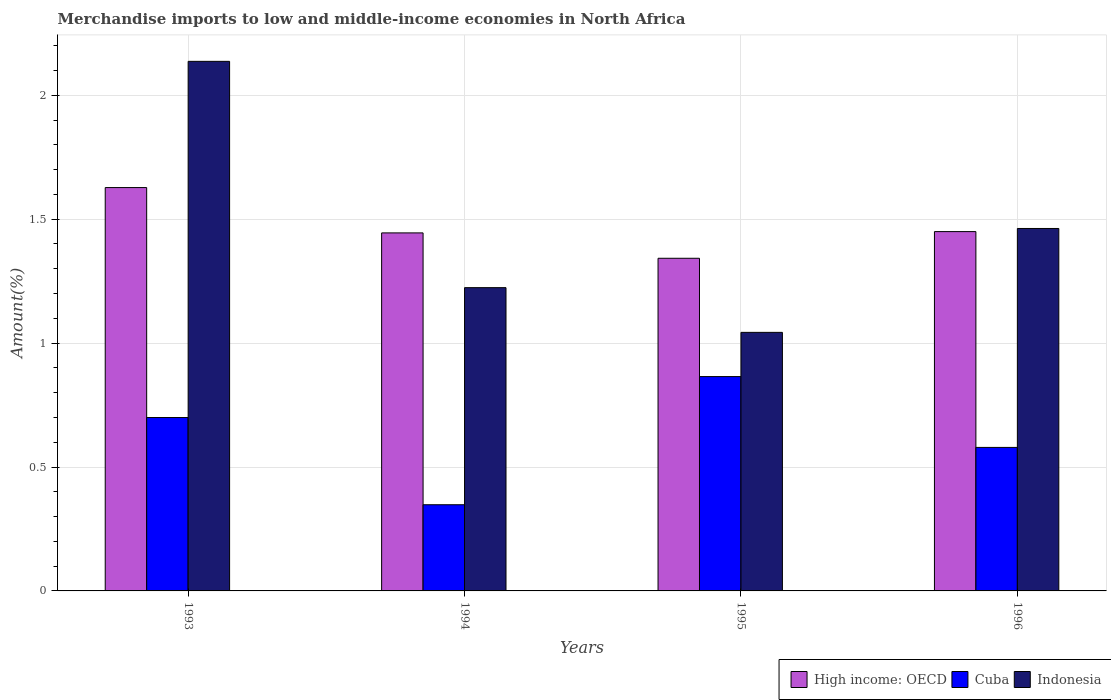How many different coloured bars are there?
Keep it short and to the point. 3. In how many cases, is the number of bars for a given year not equal to the number of legend labels?
Keep it short and to the point. 0. What is the percentage of amount earned from merchandise imports in Indonesia in 1995?
Provide a short and direct response. 1.04. Across all years, what is the maximum percentage of amount earned from merchandise imports in High income: OECD?
Your answer should be compact. 1.63. Across all years, what is the minimum percentage of amount earned from merchandise imports in High income: OECD?
Provide a succinct answer. 1.34. What is the total percentage of amount earned from merchandise imports in Cuba in the graph?
Ensure brevity in your answer.  2.49. What is the difference between the percentage of amount earned from merchandise imports in High income: OECD in 1993 and that in 1995?
Your answer should be compact. 0.29. What is the difference between the percentage of amount earned from merchandise imports in High income: OECD in 1996 and the percentage of amount earned from merchandise imports in Indonesia in 1995?
Your response must be concise. 0.41. What is the average percentage of amount earned from merchandise imports in Cuba per year?
Your answer should be compact. 0.62. In the year 1994, what is the difference between the percentage of amount earned from merchandise imports in Cuba and percentage of amount earned from merchandise imports in High income: OECD?
Your answer should be compact. -1.1. In how many years, is the percentage of amount earned from merchandise imports in Cuba greater than 1.6 %?
Give a very brief answer. 0. What is the ratio of the percentage of amount earned from merchandise imports in Indonesia in 1994 to that in 1995?
Your answer should be compact. 1.17. What is the difference between the highest and the second highest percentage of amount earned from merchandise imports in Cuba?
Give a very brief answer. 0.17. What is the difference between the highest and the lowest percentage of amount earned from merchandise imports in Cuba?
Offer a terse response. 0.52. In how many years, is the percentage of amount earned from merchandise imports in Indonesia greater than the average percentage of amount earned from merchandise imports in Indonesia taken over all years?
Provide a succinct answer. 1. What does the 1st bar from the right in 1993 represents?
Keep it short and to the point. Indonesia. Does the graph contain any zero values?
Offer a terse response. No. Does the graph contain grids?
Offer a very short reply. Yes. How many legend labels are there?
Your response must be concise. 3. How are the legend labels stacked?
Keep it short and to the point. Horizontal. What is the title of the graph?
Give a very brief answer. Merchandise imports to low and middle-income economies in North Africa. What is the label or title of the Y-axis?
Ensure brevity in your answer.  Amount(%). What is the Amount(%) in High income: OECD in 1993?
Offer a very short reply. 1.63. What is the Amount(%) in Cuba in 1993?
Give a very brief answer. 0.7. What is the Amount(%) of Indonesia in 1993?
Give a very brief answer. 2.14. What is the Amount(%) in High income: OECD in 1994?
Ensure brevity in your answer.  1.44. What is the Amount(%) in Cuba in 1994?
Offer a terse response. 0.35. What is the Amount(%) of Indonesia in 1994?
Make the answer very short. 1.22. What is the Amount(%) of High income: OECD in 1995?
Keep it short and to the point. 1.34. What is the Amount(%) in Cuba in 1995?
Your response must be concise. 0.86. What is the Amount(%) of Indonesia in 1995?
Provide a short and direct response. 1.04. What is the Amount(%) of High income: OECD in 1996?
Provide a succinct answer. 1.45. What is the Amount(%) in Cuba in 1996?
Your answer should be very brief. 0.58. What is the Amount(%) of Indonesia in 1996?
Offer a very short reply. 1.46. Across all years, what is the maximum Amount(%) of High income: OECD?
Make the answer very short. 1.63. Across all years, what is the maximum Amount(%) in Cuba?
Ensure brevity in your answer.  0.86. Across all years, what is the maximum Amount(%) in Indonesia?
Provide a short and direct response. 2.14. Across all years, what is the minimum Amount(%) in High income: OECD?
Ensure brevity in your answer.  1.34. Across all years, what is the minimum Amount(%) of Cuba?
Your answer should be compact. 0.35. Across all years, what is the minimum Amount(%) in Indonesia?
Offer a very short reply. 1.04. What is the total Amount(%) in High income: OECD in the graph?
Keep it short and to the point. 5.86. What is the total Amount(%) of Cuba in the graph?
Provide a short and direct response. 2.49. What is the total Amount(%) of Indonesia in the graph?
Your response must be concise. 5.87. What is the difference between the Amount(%) in High income: OECD in 1993 and that in 1994?
Your response must be concise. 0.18. What is the difference between the Amount(%) of Cuba in 1993 and that in 1994?
Keep it short and to the point. 0.35. What is the difference between the Amount(%) in Indonesia in 1993 and that in 1994?
Your answer should be very brief. 0.91. What is the difference between the Amount(%) of High income: OECD in 1993 and that in 1995?
Make the answer very short. 0.29. What is the difference between the Amount(%) of Cuba in 1993 and that in 1995?
Provide a short and direct response. -0.17. What is the difference between the Amount(%) of Indonesia in 1993 and that in 1995?
Offer a very short reply. 1.09. What is the difference between the Amount(%) of High income: OECD in 1993 and that in 1996?
Give a very brief answer. 0.18. What is the difference between the Amount(%) of Cuba in 1993 and that in 1996?
Provide a short and direct response. 0.12. What is the difference between the Amount(%) of Indonesia in 1993 and that in 1996?
Ensure brevity in your answer.  0.67. What is the difference between the Amount(%) in High income: OECD in 1994 and that in 1995?
Your answer should be very brief. 0.1. What is the difference between the Amount(%) in Cuba in 1994 and that in 1995?
Offer a terse response. -0.52. What is the difference between the Amount(%) of Indonesia in 1994 and that in 1995?
Offer a terse response. 0.18. What is the difference between the Amount(%) of High income: OECD in 1994 and that in 1996?
Offer a terse response. -0.01. What is the difference between the Amount(%) in Cuba in 1994 and that in 1996?
Your answer should be very brief. -0.23. What is the difference between the Amount(%) of Indonesia in 1994 and that in 1996?
Offer a terse response. -0.24. What is the difference between the Amount(%) in High income: OECD in 1995 and that in 1996?
Offer a terse response. -0.11. What is the difference between the Amount(%) of Cuba in 1995 and that in 1996?
Make the answer very short. 0.29. What is the difference between the Amount(%) in Indonesia in 1995 and that in 1996?
Your answer should be very brief. -0.42. What is the difference between the Amount(%) of High income: OECD in 1993 and the Amount(%) of Cuba in 1994?
Offer a very short reply. 1.28. What is the difference between the Amount(%) in High income: OECD in 1993 and the Amount(%) in Indonesia in 1994?
Ensure brevity in your answer.  0.4. What is the difference between the Amount(%) of Cuba in 1993 and the Amount(%) of Indonesia in 1994?
Your answer should be very brief. -0.52. What is the difference between the Amount(%) of High income: OECD in 1993 and the Amount(%) of Cuba in 1995?
Your answer should be very brief. 0.76. What is the difference between the Amount(%) in High income: OECD in 1993 and the Amount(%) in Indonesia in 1995?
Offer a terse response. 0.58. What is the difference between the Amount(%) of Cuba in 1993 and the Amount(%) of Indonesia in 1995?
Keep it short and to the point. -0.34. What is the difference between the Amount(%) in High income: OECD in 1993 and the Amount(%) in Cuba in 1996?
Your answer should be very brief. 1.05. What is the difference between the Amount(%) of High income: OECD in 1993 and the Amount(%) of Indonesia in 1996?
Offer a very short reply. 0.17. What is the difference between the Amount(%) of Cuba in 1993 and the Amount(%) of Indonesia in 1996?
Ensure brevity in your answer.  -0.76. What is the difference between the Amount(%) of High income: OECD in 1994 and the Amount(%) of Cuba in 1995?
Offer a terse response. 0.58. What is the difference between the Amount(%) in High income: OECD in 1994 and the Amount(%) in Indonesia in 1995?
Give a very brief answer. 0.4. What is the difference between the Amount(%) in Cuba in 1994 and the Amount(%) in Indonesia in 1995?
Provide a succinct answer. -0.7. What is the difference between the Amount(%) in High income: OECD in 1994 and the Amount(%) in Cuba in 1996?
Your answer should be compact. 0.87. What is the difference between the Amount(%) in High income: OECD in 1994 and the Amount(%) in Indonesia in 1996?
Provide a succinct answer. -0.02. What is the difference between the Amount(%) in Cuba in 1994 and the Amount(%) in Indonesia in 1996?
Make the answer very short. -1.11. What is the difference between the Amount(%) in High income: OECD in 1995 and the Amount(%) in Cuba in 1996?
Ensure brevity in your answer.  0.76. What is the difference between the Amount(%) of High income: OECD in 1995 and the Amount(%) of Indonesia in 1996?
Ensure brevity in your answer.  -0.12. What is the difference between the Amount(%) of Cuba in 1995 and the Amount(%) of Indonesia in 1996?
Ensure brevity in your answer.  -0.6. What is the average Amount(%) of High income: OECD per year?
Make the answer very short. 1.47. What is the average Amount(%) in Cuba per year?
Give a very brief answer. 0.62. What is the average Amount(%) in Indonesia per year?
Keep it short and to the point. 1.47. In the year 1993, what is the difference between the Amount(%) in High income: OECD and Amount(%) in Cuba?
Offer a terse response. 0.93. In the year 1993, what is the difference between the Amount(%) of High income: OECD and Amount(%) of Indonesia?
Offer a terse response. -0.51. In the year 1993, what is the difference between the Amount(%) in Cuba and Amount(%) in Indonesia?
Your response must be concise. -1.44. In the year 1994, what is the difference between the Amount(%) of High income: OECD and Amount(%) of Cuba?
Your answer should be very brief. 1.1. In the year 1994, what is the difference between the Amount(%) in High income: OECD and Amount(%) in Indonesia?
Your answer should be very brief. 0.22. In the year 1994, what is the difference between the Amount(%) in Cuba and Amount(%) in Indonesia?
Provide a short and direct response. -0.88. In the year 1995, what is the difference between the Amount(%) of High income: OECD and Amount(%) of Cuba?
Your response must be concise. 0.48. In the year 1995, what is the difference between the Amount(%) in High income: OECD and Amount(%) in Indonesia?
Your answer should be very brief. 0.3. In the year 1995, what is the difference between the Amount(%) of Cuba and Amount(%) of Indonesia?
Offer a terse response. -0.18. In the year 1996, what is the difference between the Amount(%) in High income: OECD and Amount(%) in Cuba?
Your answer should be very brief. 0.87. In the year 1996, what is the difference between the Amount(%) in High income: OECD and Amount(%) in Indonesia?
Your answer should be compact. -0.01. In the year 1996, what is the difference between the Amount(%) of Cuba and Amount(%) of Indonesia?
Offer a terse response. -0.88. What is the ratio of the Amount(%) of High income: OECD in 1993 to that in 1994?
Offer a very short reply. 1.13. What is the ratio of the Amount(%) of Cuba in 1993 to that in 1994?
Give a very brief answer. 2.01. What is the ratio of the Amount(%) of Indonesia in 1993 to that in 1994?
Offer a very short reply. 1.75. What is the ratio of the Amount(%) of High income: OECD in 1993 to that in 1995?
Your response must be concise. 1.21. What is the ratio of the Amount(%) in Cuba in 1993 to that in 1995?
Give a very brief answer. 0.81. What is the ratio of the Amount(%) in Indonesia in 1993 to that in 1995?
Keep it short and to the point. 2.05. What is the ratio of the Amount(%) in High income: OECD in 1993 to that in 1996?
Ensure brevity in your answer.  1.12. What is the ratio of the Amount(%) of Cuba in 1993 to that in 1996?
Your answer should be compact. 1.21. What is the ratio of the Amount(%) of Indonesia in 1993 to that in 1996?
Your response must be concise. 1.46. What is the ratio of the Amount(%) in High income: OECD in 1994 to that in 1995?
Provide a short and direct response. 1.08. What is the ratio of the Amount(%) in Cuba in 1994 to that in 1995?
Your answer should be very brief. 0.4. What is the ratio of the Amount(%) in Indonesia in 1994 to that in 1995?
Your answer should be very brief. 1.17. What is the ratio of the Amount(%) in Cuba in 1994 to that in 1996?
Ensure brevity in your answer.  0.6. What is the ratio of the Amount(%) of Indonesia in 1994 to that in 1996?
Provide a succinct answer. 0.84. What is the ratio of the Amount(%) in High income: OECD in 1995 to that in 1996?
Provide a short and direct response. 0.93. What is the ratio of the Amount(%) in Cuba in 1995 to that in 1996?
Give a very brief answer. 1.49. What is the ratio of the Amount(%) of Indonesia in 1995 to that in 1996?
Make the answer very short. 0.71. What is the difference between the highest and the second highest Amount(%) in High income: OECD?
Offer a very short reply. 0.18. What is the difference between the highest and the second highest Amount(%) of Cuba?
Offer a very short reply. 0.17. What is the difference between the highest and the second highest Amount(%) of Indonesia?
Provide a short and direct response. 0.67. What is the difference between the highest and the lowest Amount(%) in High income: OECD?
Your answer should be very brief. 0.29. What is the difference between the highest and the lowest Amount(%) in Cuba?
Ensure brevity in your answer.  0.52. What is the difference between the highest and the lowest Amount(%) of Indonesia?
Keep it short and to the point. 1.09. 